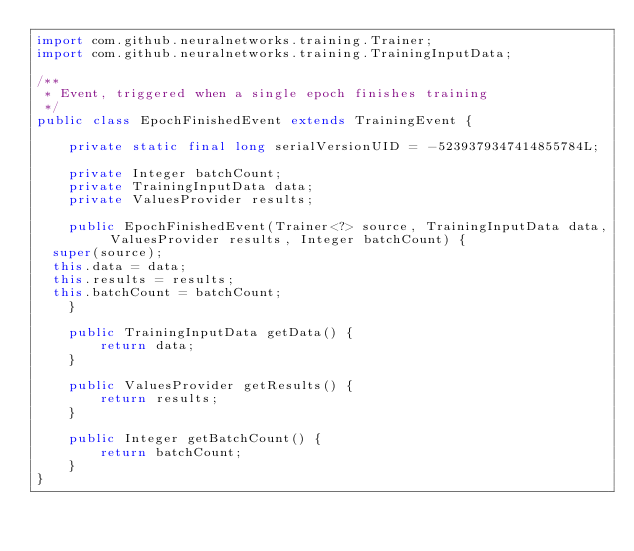<code> <loc_0><loc_0><loc_500><loc_500><_Java_>import com.github.neuralnetworks.training.Trainer;
import com.github.neuralnetworks.training.TrainingInputData;

/**
 * Event, triggered when a single epoch finishes training
 */
public class EpochFinishedEvent extends TrainingEvent {

    private static final long serialVersionUID = -5239379347414855784L;

    private Integer batchCount;
    private TrainingInputData data;
    private ValuesProvider results;

    public EpochFinishedEvent(Trainer<?> source, TrainingInputData data, ValuesProvider results, Integer batchCount) {
	super(source);
	this.data = data;
	this.results = results;
	this.batchCount = batchCount;
    }

    public TrainingInputData getData() {
        return data;
    }

    public ValuesProvider getResults() {
        return results;
    }

    public Integer getBatchCount() {
        return batchCount;
    }
}
</code> 